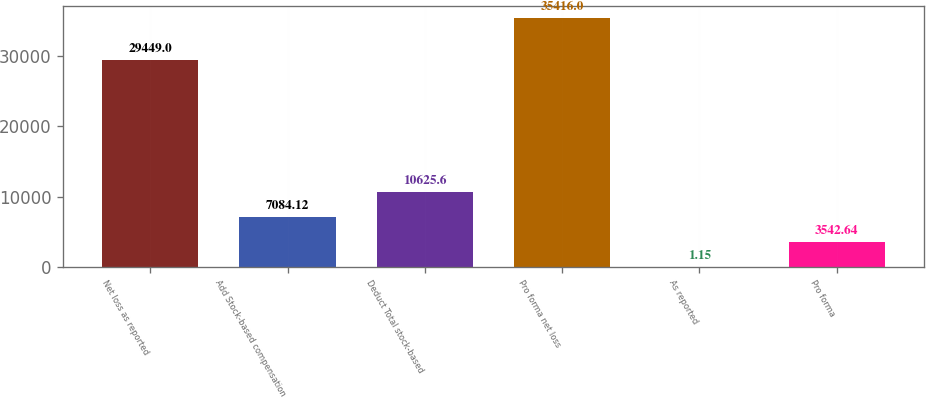Convert chart. <chart><loc_0><loc_0><loc_500><loc_500><bar_chart><fcel>Net loss as reported<fcel>Add Stock-based compensation<fcel>Deduct Total stock-based<fcel>Pro forma net loss<fcel>As reported<fcel>Pro forma<nl><fcel>29449<fcel>7084.12<fcel>10625.6<fcel>35416<fcel>1.15<fcel>3542.64<nl></chart> 